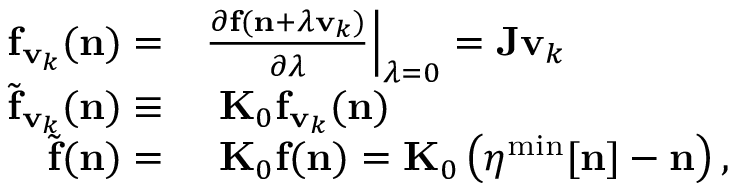Convert formula to latex. <formula><loc_0><loc_0><loc_500><loc_500>\begin{array} { r l } { { f } _ { { v } _ { k } } ( { n } ) = } & { \frac { \partial { f } ( { n } + \lambda { v } _ { k } ) } { \partial \lambda } \Big | _ { \lambda = 0 } = { J } { v } _ { k } } \\ { { \widetilde { f } } _ { { v } _ { k } } ( { n } ) \equiv } & { { K } _ { 0 } { f } _ { { v } _ { k } } ( { n } ) } \\ { { \widetilde { f } } { ( n ) } = } & { { K } _ { 0 } { f ( n ) } = { K } _ { 0 } \left ( { \boldsymbol \eta } ^ { \min } [ { n } ] - { n } \right ) , } \end{array}</formula> 